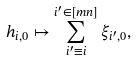Convert formula to latex. <formula><loc_0><loc_0><loc_500><loc_500>h _ { i , 0 } \mapsto \sum ^ { i ^ { \prime } \in [ m n ] } _ { i ^ { \prime } \equiv i } \xi _ { i ^ { \prime } , 0 } ,</formula> 